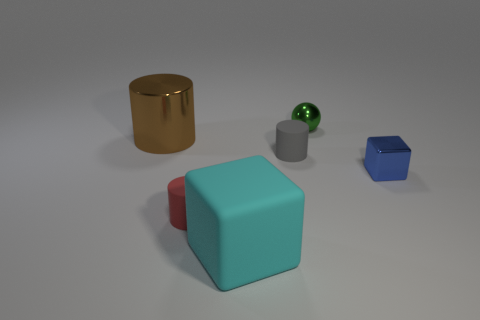Is the number of tiny gray objects behind the large brown metal object greater than the number of large brown metallic cylinders that are right of the blue shiny block?
Provide a succinct answer. No. Do the big object that is right of the brown metal object and the small cylinder that is in front of the tiny gray rubber cylinder have the same material?
Your response must be concise. Yes. There is a red matte cylinder; are there any small things behind it?
Offer a terse response. Yes. What number of red objects are balls or big cylinders?
Offer a very short reply. 0. Do the brown cylinder and the block that is on the right side of the green thing have the same material?
Provide a succinct answer. Yes. What size is the other object that is the same shape as the tiny blue metallic object?
Offer a very short reply. Large. What is the gray cylinder made of?
Offer a terse response. Rubber. There is a small cylinder that is behind the small rubber cylinder left of the small rubber cylinder that is behind the blue metallic cube; what is its material?
Your answer should be compact. Rubber. There is a metal object behind the large shiny object; is its size the same as the shiny thing that is to the left of the cyan cube?
Provide a short and direct response. No. What number of other objects are the same material as the big cyan object?
Provide a succinct answer. 2. 